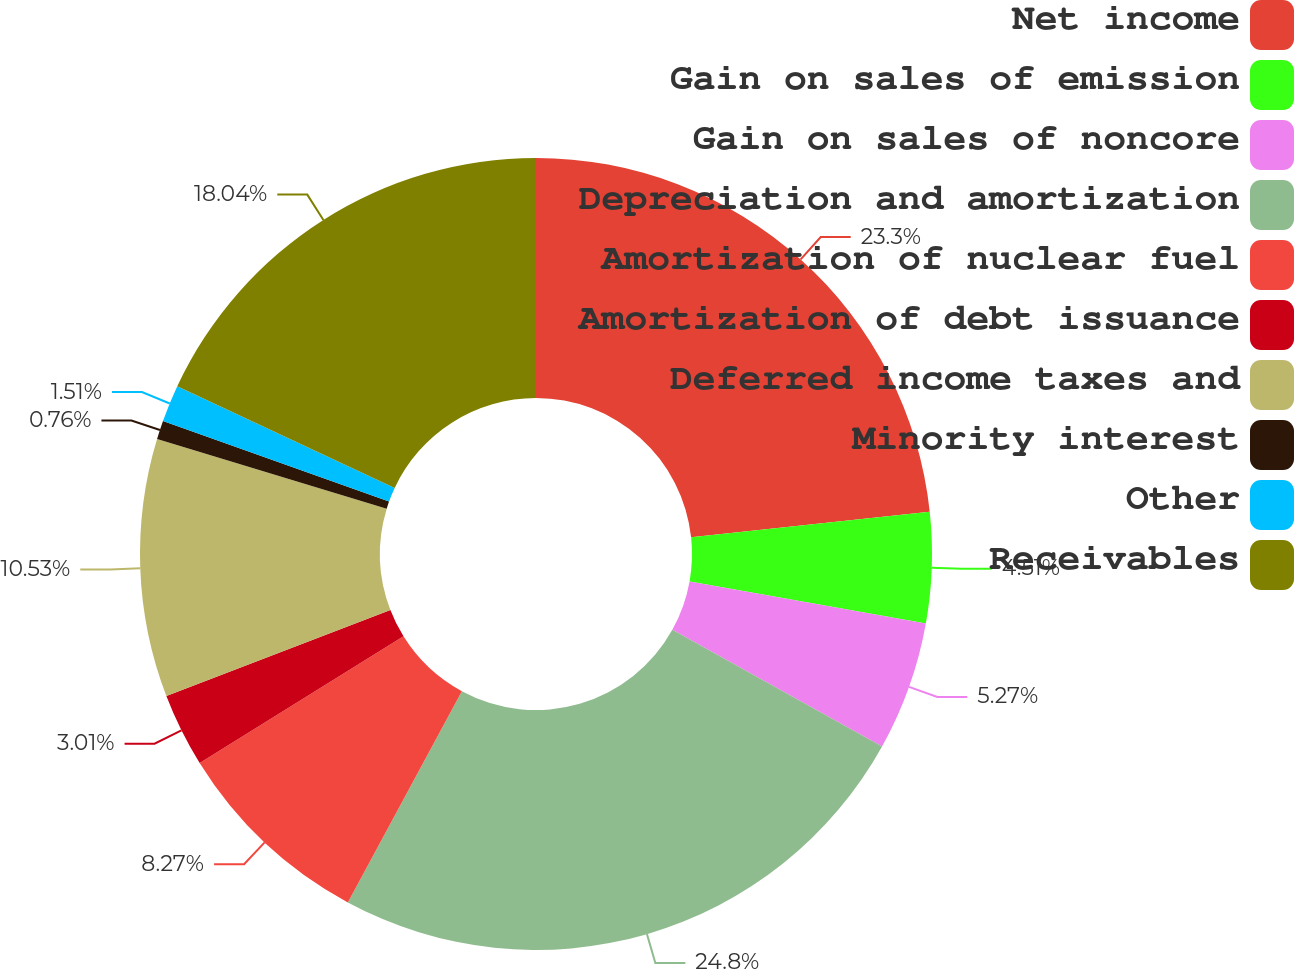Convert chart to OTSL. <chart><loc_0><loc_0><loc_500><loc_500><pie_chart><fcel>Net income<fcel>Gain on sales of emission<fcel>Gain on sales of noncore<fcel>Depreciation and amortization<fcel>Amortization of nuclear fuel<fcel>Amortization of debt issuance<fcel>Deferred income taxes and<fcel>Minority interest<fcel>Other<fcel>Receivables<nl><fcel>23.3%<fcel>4.51%<fcel>5.27%<fcel>24.8%<fcel>8.27%<fcel>3.01%<fcel>10.53%<fcel>0.76%<fcel>1.51%<fcel>18.04%<nl></chart> 